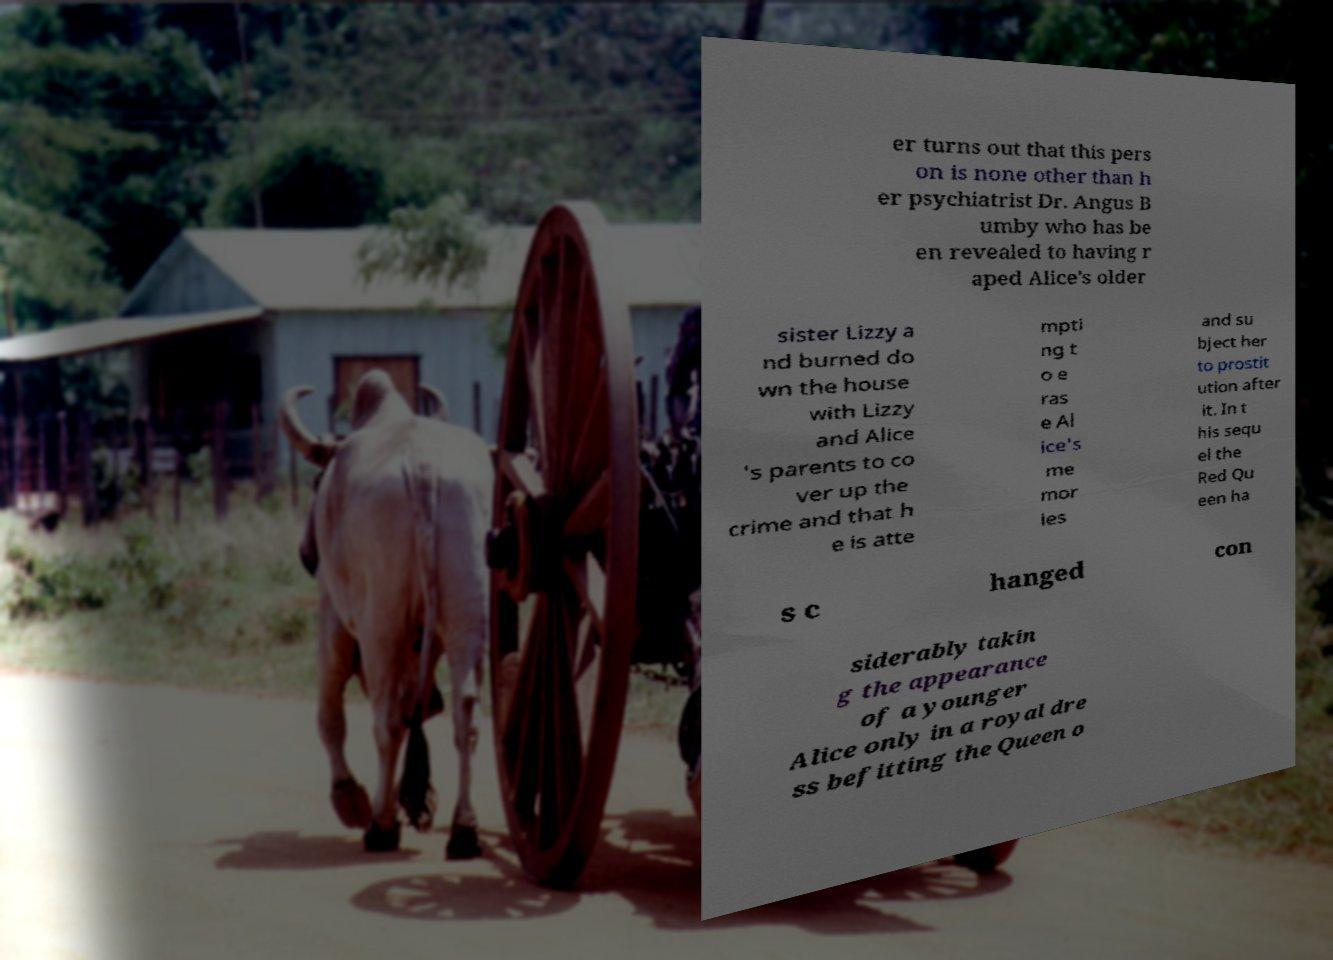Could you assist in decoding the text presented in this image and type it out clearly? er turns out that this pers on is none other than h er psychiatrist Dr. Angus B umby who has be en revealed to having r aped Alice's older sister Lizzy a nd burned do wn the house with Lizzy and Alice 's parents to co ver up the crime and that h e is atte mpti ng t o e ras e Al ice's me mor ies and su bject her to prostit ution after it. In t his sequ el the Red Qu een ha s c hanged con siderably takin g the appearance of a younger Alice only in a royal dre ss befitting the Queen o 